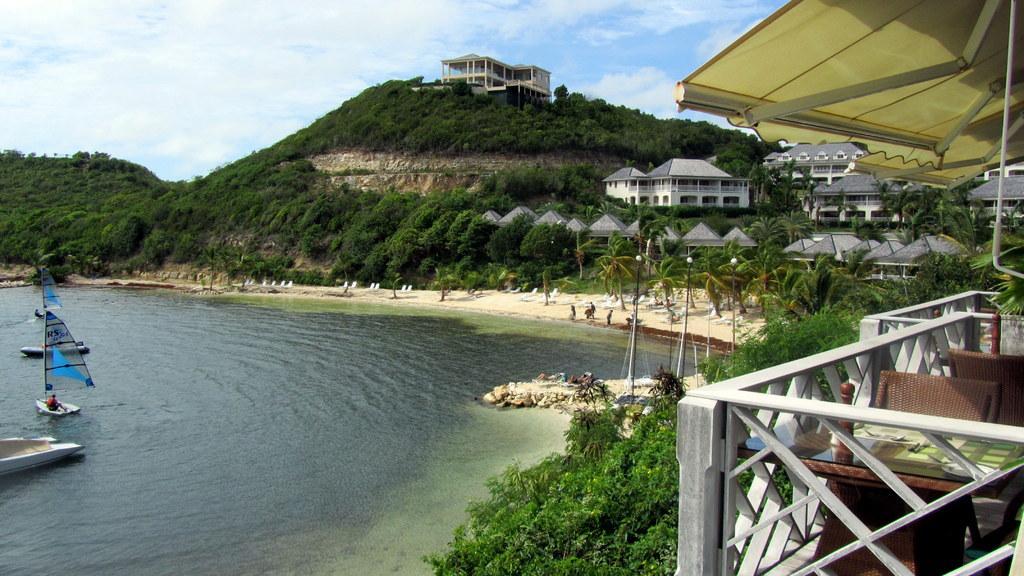How would you summarize this image in a sentence or two? In this image I can see a table, few chairs, the white colored railing, few trees, few buildings and the water. In the background I can see few boats in the water, a mountain, a building on a mountain, few persons on the beach and the sky. 